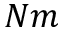<formula> <loc_0><loc_0><loc_500><loc_500>N m</formula> 